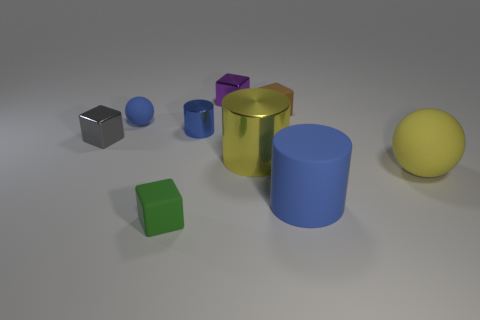Add 1 small green blocks. How many objects exist? 10 Subtract all cubes. How many objects are left? 5 Subtract 0 brown cylinders. How many objects are left? 9 Subtract all purple cubes. Subtract all big cyan cubes. How many objects are left? 8 Add 5 large yellow cylinders. How many large yellow cylinders are left? 6 Add 3 matte blocks. How many matte blocks exist? 5 